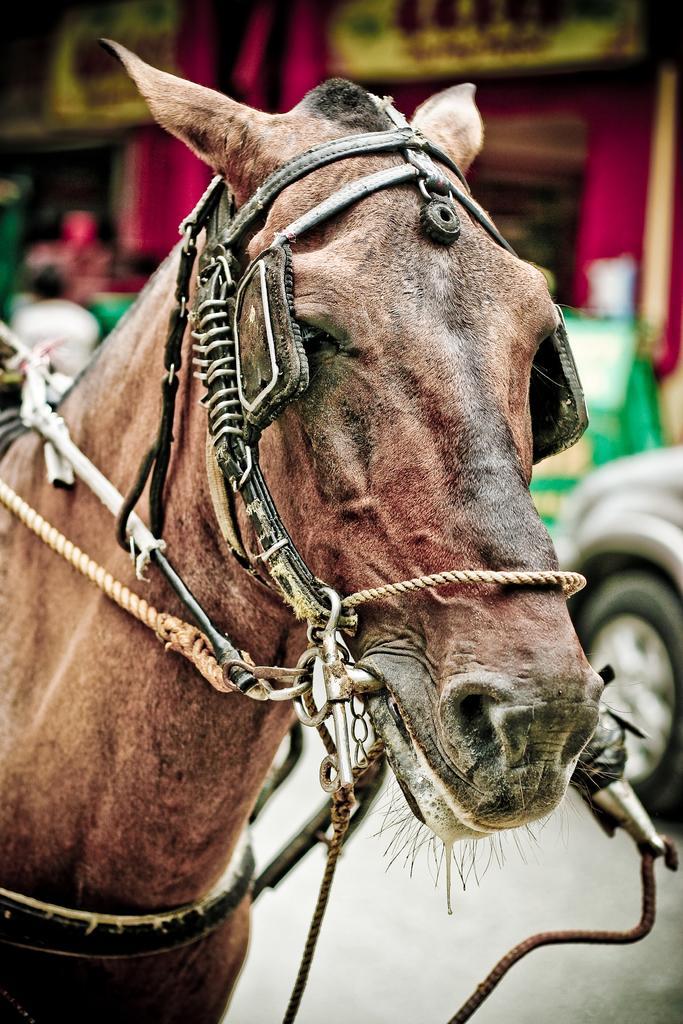How would you summarize this image in a sentence or two? In this image we can see horse and there are belts and ropes tied to the face of the horse. In the background the image is blur but we can see objects, person and a vehicle on the road. 